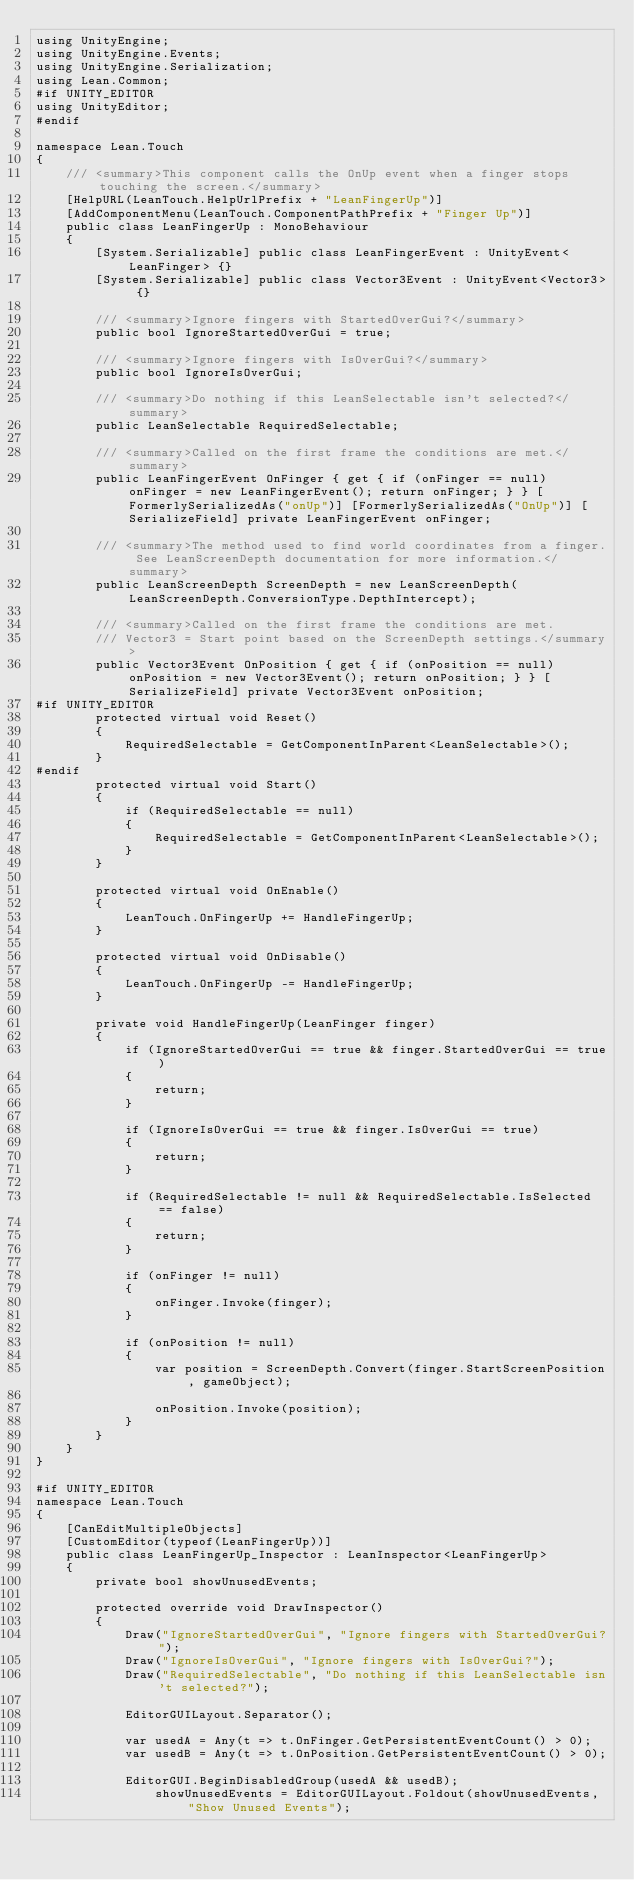<code> <loc_0><loc_0><loc_500><loc_500><_C#_>using UnityEngine;
using UnityEngine.Events;
using UnityEngine.Serialization;
using Lean.Common;
#if UNITY_EDITOR
using UnityEditor;
#endif

namespace Lean.Touch
{
	/// <summary>This component calls the OnUp event when a finger stops touching the screen.</summary>
	[HelpURL(LeanTouch.HelpUrlPrefix + "LeanFingerUp")]
	[AddComponentMenu(LeanTouch.ComponentPathPrefix + "Finger Up")]
	public class LeanFingerUp : MonoBehaviour
	{
		[System.Serializable] public class LeanFingerEvent : UnityEvent<LeanFinger> {}
		[System.Serializable] public class Vector3Event : UnityEvent<Vector3> {}

		/// <summary>Ignore fingers with StartedOverGui?</summary>
		public bool IgnoreStartedOverGui = true;

		/// <summary>Ignore fingers with IsOverGui?</summary>
		public bool IgnoreIsOverGui;

		/// <summary>Do nothing if this LeanSelectable isn't selected?</summary>
		public LeanSelectable RequiredSelectable;

		/// <summary>Called on the first frame the conditions are met.</summary>
		public LeanFingerEvent OnFinger { get { if (onFinger == null) onFinger = new LeanFingerEvent(); return onFinger; } } [FormerlySerializedAs("onUp")] [FormerlySerializedAs("OnUp")] [SerializeField] private LeanFingerEvent onFinger;
		
		/// <summary>The method used to find world coordinates from a finger. See LeanScreenDepth documentation for more information.</summary>
		public LeanScreenDepth ScreenDepth = new LeanScreenDepth(LeanScreenDepth.ConversionType.DepthIntercept);

		/// <summary>Called on the first frame the conditions are met.
		/// Vector3 = Start point based on the ScreenDepth settings.</summary>
		public Vector3Event OnPosition { get { if (onPosition == null) onPosition = new Vector3Event(); return onPosition; } } [SerializeField] private Vector3Event onPosition;
#if UNITY_EDITOR
		protected virtual void Reset()
		{
			RequiredSelectable = GetComponentInParent<LeanSelectable>();
		}
#endif
		protected virtual void Start()
		{
			if (RequiredSelectable == null)
			{
				RequiredSelectable = GetComponentInParent<LeanSelectable>();
			}
		}

		protected virtual void OnEnable()
		{
			LeanTouch.OnFingerUp += HandleFingerUp;
		}

		protected virtual void OnDisable()
		{
			LeanTouch.OnFingerUp -= HandleFingerUp;
		}

		private void HandleFingerUp(LeanFinger finger)
		{
			if (IgnoreStartedOverGui == true && finger.StartedOverGui == true)
			{
				return;
			}

			if (IgnoreIsOverGui == true && finger.IsOverGui == true)
			{
				return;
			}

			if (RequiredSelectable != null && RequiredSelectable.IsSelected == false)
			{
				return;
			}

			if (onFinger != null)
			{
				onFinger.Invoke(finger);
			}

			if (onPosition != null)
			{
				var position = ScreenDepth.Convert(finger.StartScreenPosition, gameObject);

				onPosition.Invoke(position);
			}
		}
	}
}

#if UNITY_EDITOR
namespace Lean.Touch
{
	[CanEditMultipleObjects]
	[CustomEditor(typeof(LeanFingerUp))]
	public class LeanFingerUp_Inspector : LeanInspector<LeanFingerUp>
	{
		private bool showUnusedEvents;

		protected override void DrawInspector()
		{
			Draw("IgnoreStartedOverGui", "Ignore fingers with StartedOverGui?");
			Draw("IgnoreIsOverGui", "Ignore fingers with IsOverGui?");
			Draw("RequiredSelectable", "Do nothing if this LeanSelectable isn't selected?");

			EditorGUILayout.Separator();

			var usedA = Any(t => t.OnFinger.GetPersistentEventCount() > 0);
			var usedB = Any(t => t.OnPosition.GetPersistentEventCount() > 0);

			EditorGUI.BeginDisabledGroup(usedA && usedB);
				showUnusedEvents = EditorGUILayout.Foldout(showUnusedEvents, "Show Unused Events");</code> 